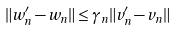<formula> <loc_0><loc_0><loc_500><loc_500>\| w _ { n } ^ { \prime } - w _ { n } \| \leq \gamma _ { n } \| v _ { n } ^ { \prime } - v _ { n } \|</formula> 